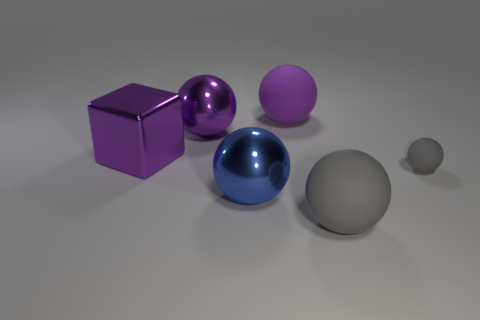Subtract all blue balls. How many balls are left? 4 Subtract all big gray balls. How many balls are left? 4 Subtract all cyan spheres. Subtract all blue cylinders. How many spheres are left? 5 Add 2 large cubes. How many objects exist? 8 Subtract all blocks. How many objects are left? 5 Subtract 1 gray balls. How many objects are left? 5 Subtract all big blocks. Subtract all matte cylinders. How many objects are left? 5 Add 2 tiny gray rubber objects. How many tiny gray rubber objects are left? 3 Add 3 large purple shiny balls. How many large purple shiny balls exist? 4 